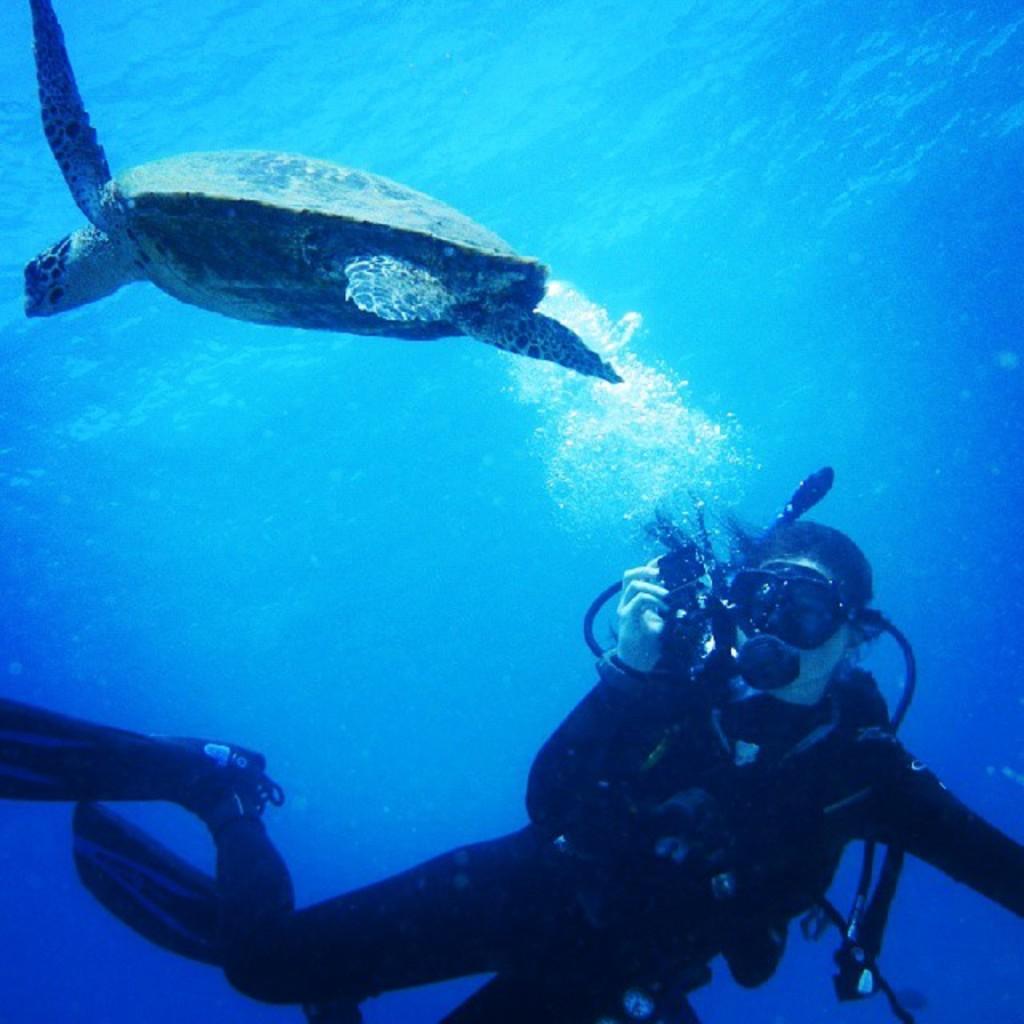How would you summarize this image in a sentence or two? As we can see in the image there is a fish, person and water. 